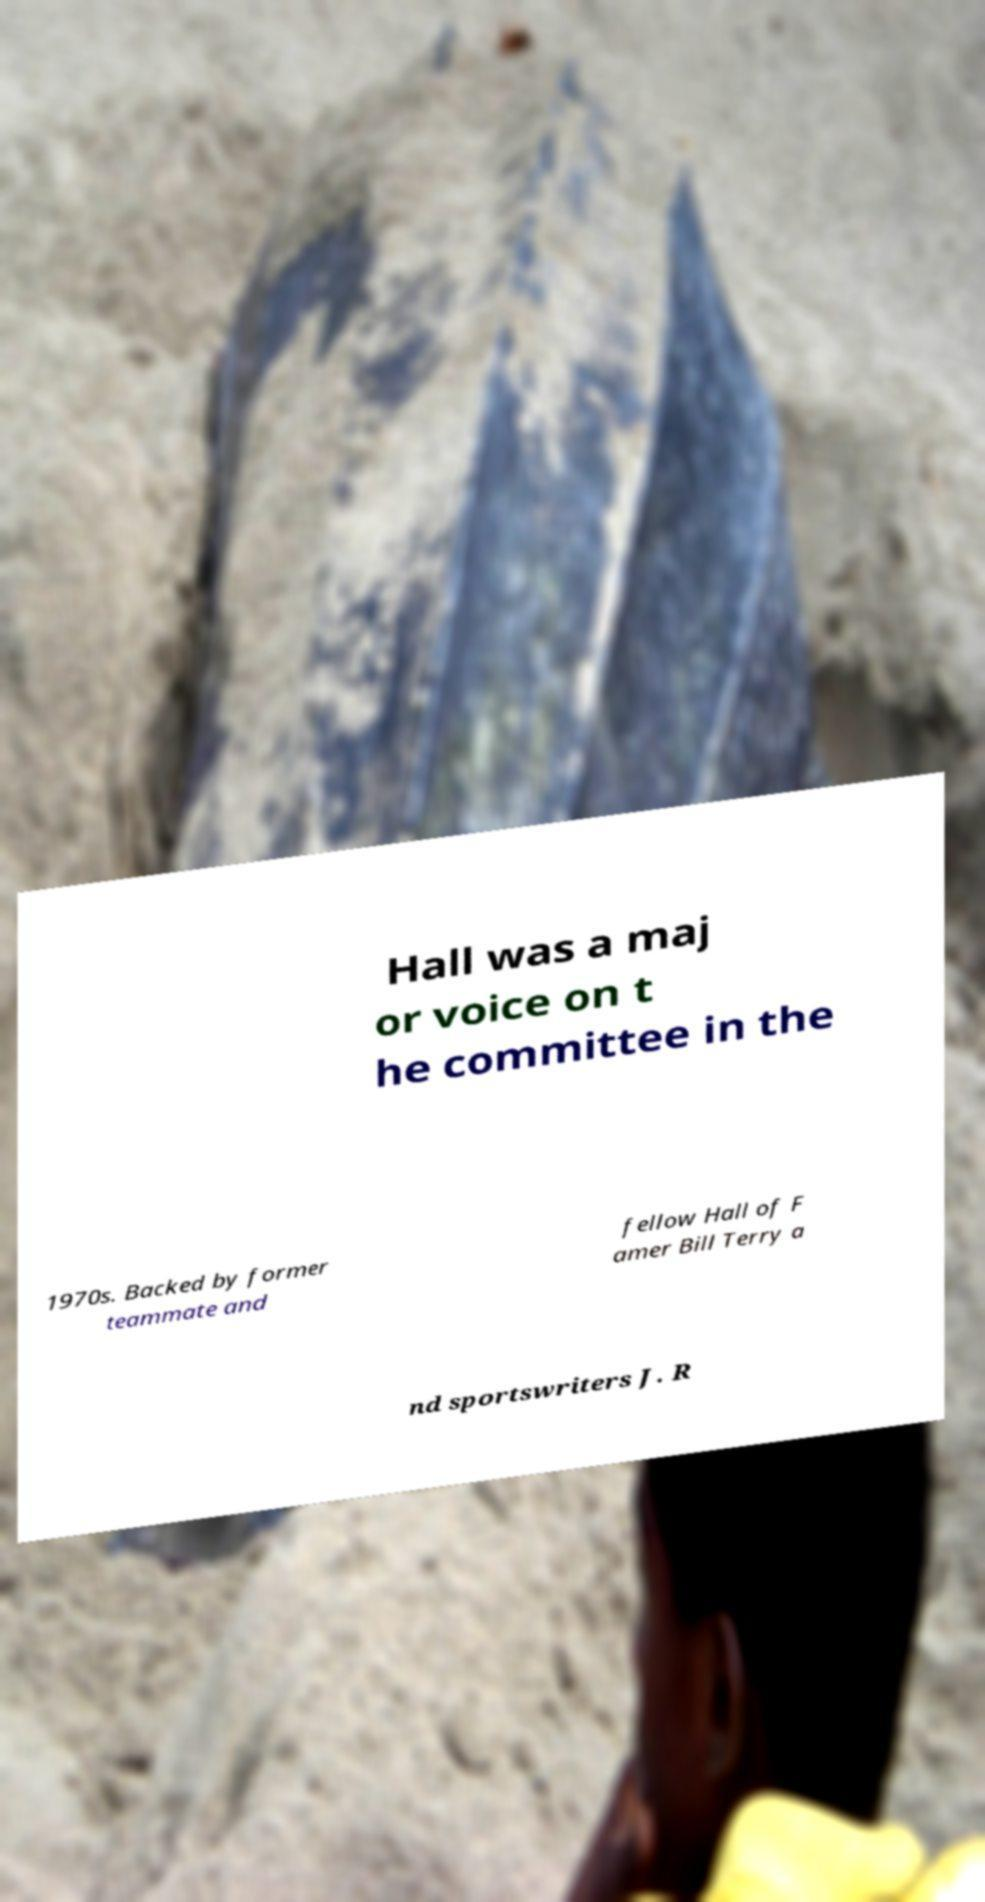Can you accurately transcribe the text from the provided image for me? Hall was a maj or voice on t he committee in the 1970s. Backed by former teammate and fellow Hall of F amer Bill Terry a nd sportswriters J. R 